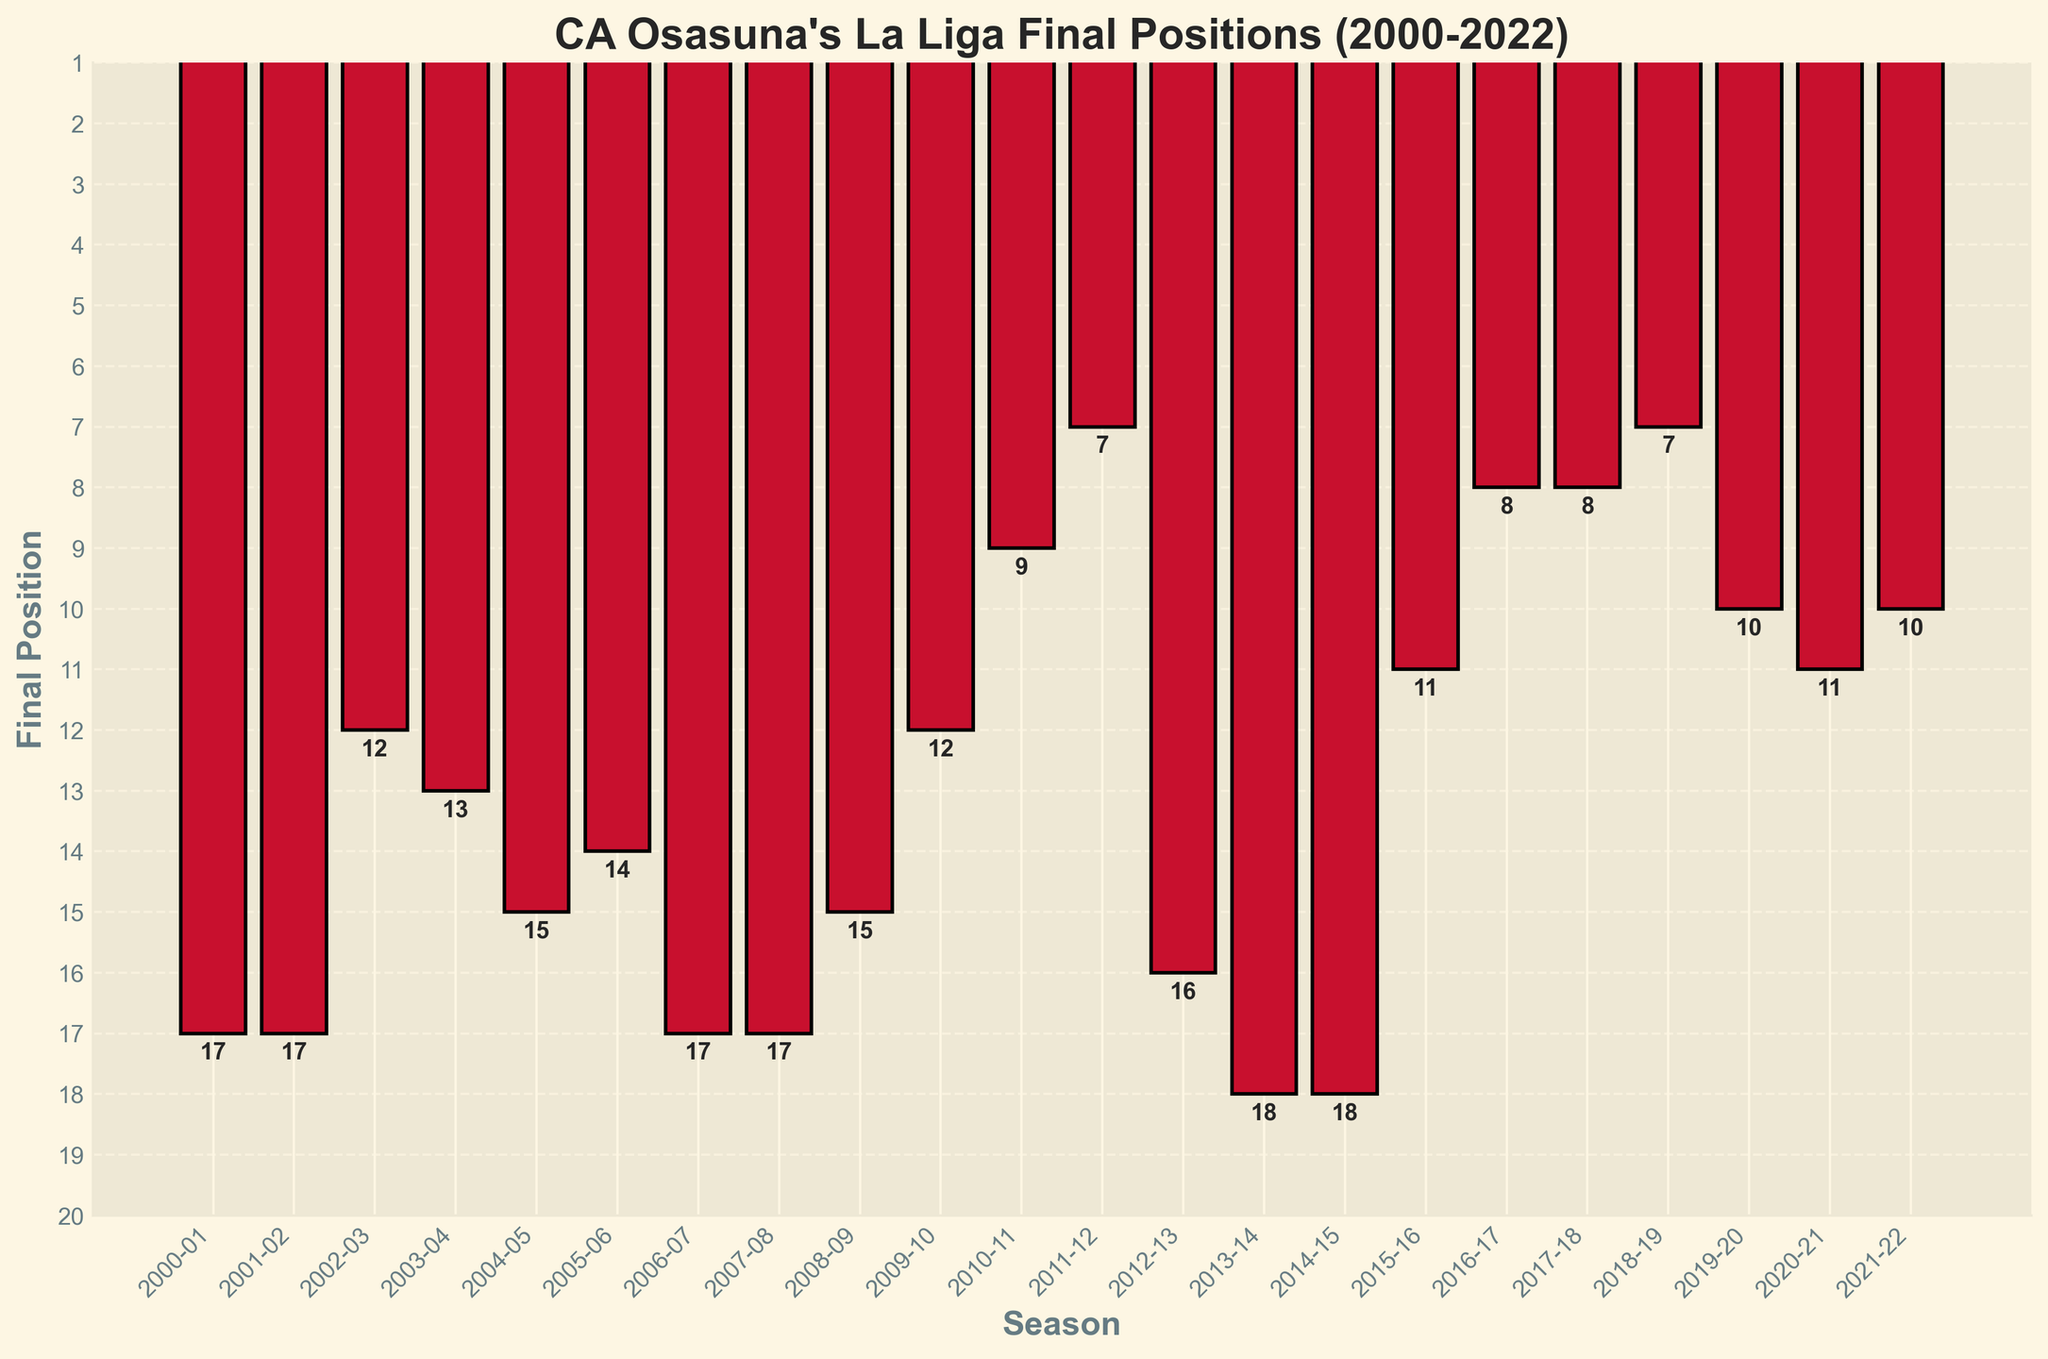What was CA Osasuna's best final position in La Liga between 2000 and 2022? The best position is represented by the shortest bar in the plot, corresponding to the minimum value on the y-axis. The lowest bar is in the 2011-12 season, marked as 7.
Answer: 7 In which seasons did CA Osasuna finish in 17th place? By identifying the bars reaching the position labeled 17 on the y-axis, we can see that CA Osasuna finished 17th in 2000-01, 2001-02, 2006-07, and 2007-08.
Answer: 2000-01, 2001-02, 2006-07, 2007-08 How many times did CA Osasuna finish in the top 10 between 2000 and 2022? Count the number of bars reaching values less than or equal to 10. The seasons where CA Osasuna finished in the top 10 are 2010-11, 2011-12, 2016-17, 2017-18, 2018-19, 2019-20, and 2021-22, totaling 7 times.
Answer: 7 Which season had the worst final position for CA Osasuna, and what was that position? The tallest bar represents the worst position, which is 18. They finished in this position during the 2013-14 and 2014-15 seasons.
Answer: 2013-14 and 2014-15, 18 Did CA Osasuna improve, worsen, or maintain their final position from the 2010-11 season to the 2011-12 season? Compare the height of the bars for 2010-11 and 2011-12. The bar for 2011-12 is shorter because 7 is a better position than 9, indicating an improvement.
Answer: Improve Between which consecutive seasons did CA Osasuna show the greatest improvement? Look for the largest decrease in bar height (improved position) between consecutive seasons. The biggest improvement is from 2018-19 (7th) to 2019-20 (10th), which is not an improvement. The biggest improvement is from 2012-13 (16th) to 2013-14 (18th), which is the worst position. By checking more closely, the biggest improvement is from 2009-10 (12th) to 2010-11 (9th).
Answer: 2009-10 to 2010-11 What is the average final position of CA Osasuna from 2015-16 to 2021-22? Sum the final positions from those seasons (11 + 8 + 8 + 7 + 10 + 11 + 10) = 65 and divide by the number of seasons (7) to get 65/7, which is approximately 9.29.
Answer: 9.29 In which seasons did CA Osasuna finish in the same position, and what were those positions? Look for bars reaching the same height on the y-axis. They finished 17th in 2000-01, 2001-02, 2006-07, and 2007-08 and 18th in 2013-14, and 2014-15.
Answer: 2000-01, 2001-02, 2006-07, 2007-08 (Position: 17); 2013-14, 2014-15 (Position: 18) Which season is visually represented by the shortest bar and what does it indicate? The shortest bar indicates the best final position which is the 2011-12 season with a position of 7.
Answer: 2011-12, 7 